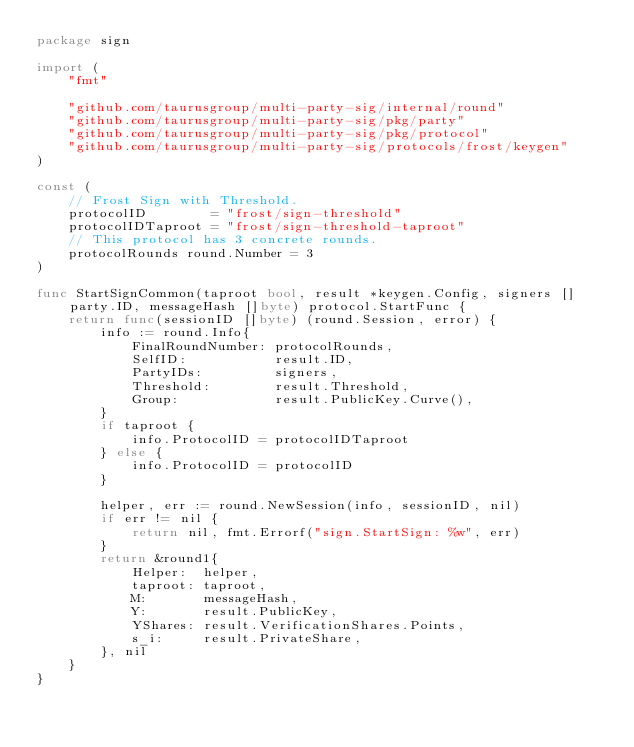<code> <loc_0><loc_0><loc_500><loc_500><_Go_>package sign

import (
	"fmt"

	"github.com/taurusgroup/multi-party-sig/internal/round"
	"github.com/taurusgroup/multi-party-sig/pkg/party"
	"github.com/taurusgroup/multi-party-sig/pkg/protocol"
	"github.com/taurusgroup/multi-party-sig/protocols/frost/keygen"
)

const (
	// Frost Sign with Threshold.
	protocolID        = "frost/sign-threshold"
	protocolIDTaproot = "frost/sign-threshold-taproot"
	// This protocol has 3 concrete rounds.
	protocolRounds round.Number = 3
)

func StartSignCommon(taproot bool, result *keygen.Config, signers []party.ID, messageHash []byte) protocol.StartFunc {
	return func(sessionID []byte) (round.Session, error) {
		info := round.Info{
			FinalRoundNumber: protocolRounds,
			SelfID:           result.ID,
			PartyIDs:         signers,
			Threshold:        result.Threshold,
			Group:            result.PublicKey.Curve(),
		}
		if taproot {
			info.ProtocolID = protocolIDTaproot
		} else {
			info.ProtocolID = protocolID
		}

		helper, err := round.NewSession(info, sessionID, nil)
		if err != nil {
			return nil, fmt.Errorf("sign.StartSign: %w", err)
		}
		return &round1{
			Helper:  helper,
			taproot: taproot,
			M:       messageHash,
			Y:       result.PublicKey,
			YShares: result.VerificationShares.Points,
			s_i:     result.PrivateShare,
		}, nil
	}
}
</code> 